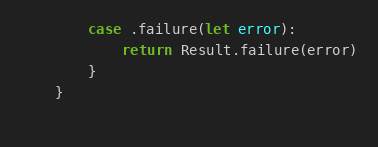<code> <loc_0><loc_0><loc_500><loc_500><_Swift_>        case .failure(let error):
            return Result.failure(error)
        }
    }
    </code> 